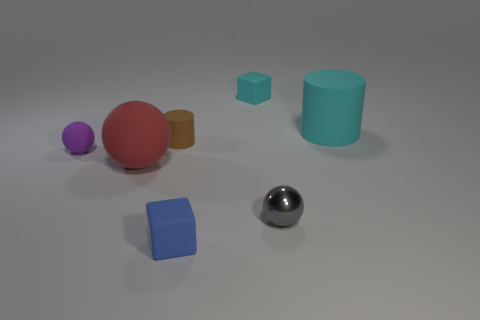What number of cyan things are small rubber cylinders or large spheres?
Your response must be concise. 0. What color is the small matte cylinder?
Your answer should be very brief. Brown. Are there any other things that have the same material as the gray thing?
Keep it short and to the point. No. Is the number of big matte things behind the brown cylinder less than the number of balls on the left side of the small gray metal ball?
Your answer should be compact. Yes. What shape is the tiny object that is in front of the brown rubber cylinder and behind the tiny shiny sphere?
Provide a succinct answer. Sphere. What number of blue rubber objects are the same shape as the purple object?
Your response must be concise. 0. The purple thing that is made of the same material as the red sphere is what size?
Ensure brevity in your answer.  Small. How many matte spheres have the same size as the cyan cylinder?
Keep it short and to the point. 1. The tiny matte object that is behind the large object that is behind the small brown rubber thing is what color?
Give a very brief answer. Cyan. Are there any tiny rubber blocks of the same color as the big cylinder?
Your response must be concise. Yes. 